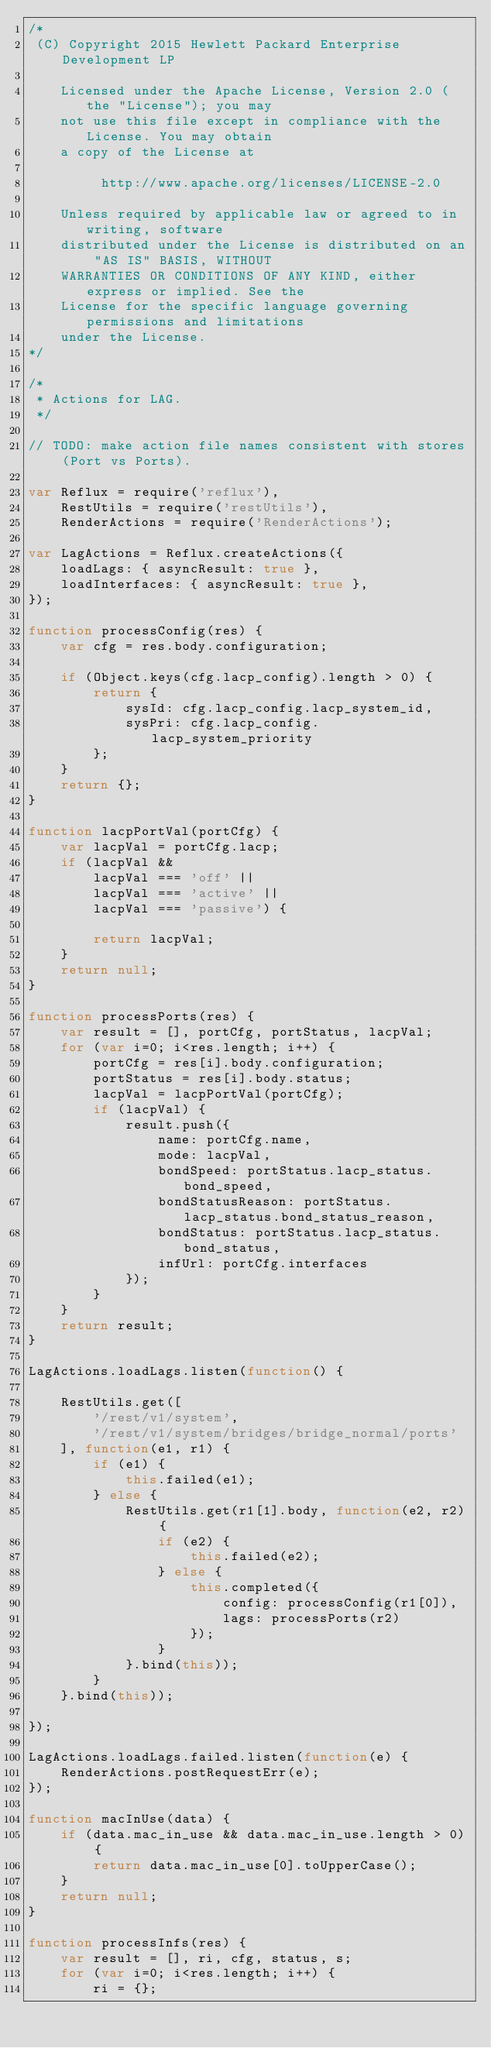Convert code to text. <code><loc_0><loc_0><loc_500><loc_500><_JavaScript_>/*
 (C) Copyright 2015 Hewlett Packard Enterprise Development LP

    Licensed under the Apache License, Version 2.0 (the "License"); you may
    not use this file except in compliance with the License. You may obtain
    a copy of the License at

         http://www.apache.org/licenses/LICENSE-2.0

    Unless required by applicable law or agreed to in writing, software
    distributed under the License is distributed on an "AS IS" BASIS, WITHOUT
    WARRANTIES OR CONDITIONS OF ANY KIND, either express or implied. See the
    License for the specific language governing permissions and limitations
    under the License.
*/

/*
 * Actions for LAG.
 */

// TODO: make action file names consistent with stores (Port vs Ports).

var Reflux = require('reflux'),
    RestUtils = require('restUtils'),
    RenderActions = require('RenderActions');

var LagActions = Reflux.createActions({
    loadLags: { asyncResult: true },
    loadInterfaces: { asyncResult: true },
});

function processConfig(res) {
    var cfg = res.body.configuration;

    if (Object.keys(cfg.lacp_config).length > 0) {
        return {
            sysId: cfg.lacp_config.lacp_system_id,
            sysPri: cfg.lacp_config.lacp_system_priority
        };
    }
    return {};
}

function lacpPortVal(portCfg) {
    var lacpVal = portCfg.lacp;
    if (lacpVal &&
        lacpVal === 'off' ||
        lacpVal === 'active' ||
        lacpVal === 'passive') {

        return lacpVal;
    }
    return null;
}

function processPorts(res) {
    var result = [], portCfg, portStatus, lacpVal;
    for (var i=0; i<res.length; i++) {
        portCfg = res[i].body.configuration;
        portStatus = res[i].body.status;
        lacpVal = lacpPortVal(portCfg);
        if (lacpVal) {
            result.push({
                name: portCfg.name,
                mode: lacpVal,
                bondSpeed: portStatus.lacp_status.bond_speed,
                bondStatusReason: portStatus.lacp_status.bond_status_reason,
                bondStatus: portStatus.lacp_status.bond_status,
                infUrl: portCfg.interfaces
            });
        }
    }
    return result;
}

LagActions.loadLags.listen(function() {

    RestUtils.get([
        '/rest/v1/system',
        '/rest/v1/system/bridges/bridge_normal/ports'
    ], function(e1, r1) {
        if (e1) {
            this.failed(e1);
        } else {
            RestUtils.get(r1[1].body, function(e2, r2) {
                if (e2) {
                    this.failed(e2);
                } else {
                    this.completed({
                        config: processConfig(r1[0]),
                        lags: processPorts(r2)
                    });
                }
            }.bind(this));
        }
    }.bind(this));

});

LagActions.loadLags.failed.listen(function(e) {
    RenderActions.postRequestErr(e);
});

function macInUse(data) {
    if (data.mac_in_use && data.mac_in_use.length > 0) {
        return data.mac_in_use[0].toUpperCase();
    }
    return null;
}

function processInfs(res) {
    var result = [], ri, cfg, status, s;
    for (var i=0; i<res.length; i++) {
        ri = {};</code> 